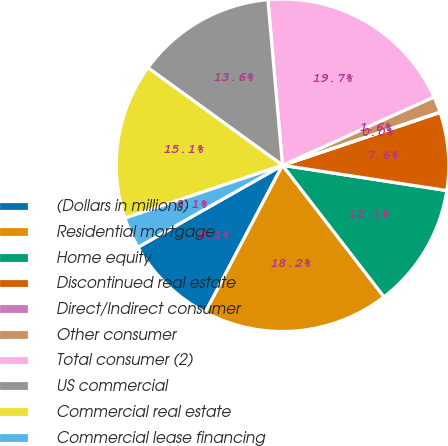<chart> <loc_0><loc_0><loc_500><loc_500><pie_chart><fcel>(Dollars in millions)<fcel>Residential mortgage<fcel>Home equity<fcel>Discontinued real estate<fcel>Direct/Indirect consumer<fcel>Other consumer<fcel>Total consumer (2)<fcel>US commercial<fcel>Commercial real estate<fcel>Commercial lease financing<nl><fcel>9.09%<fcel>18.15%<fcel>12.11%<fcel>7.58%<fcel>0.04%<fcel>1.55%<fcel>19.66%<fcel>13.62%<fcel>15.13%<fcel>3.06%<nl></chart> 